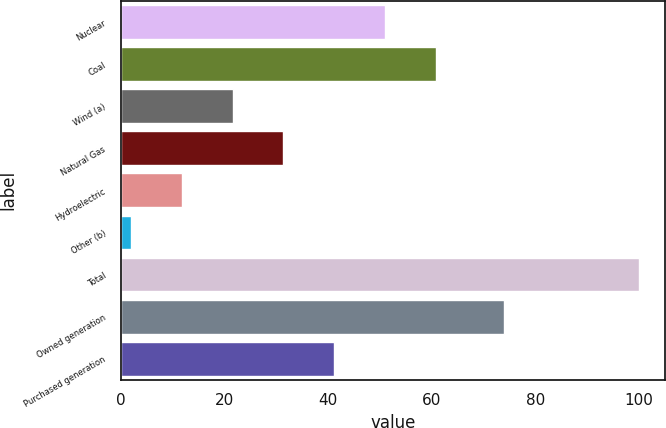Convert chart to OTSL. <chart><loc_0><loc_0><loc_500><loc_500><bar_chart><fcel>Nuclear<fcel>Coal<fcel>Wind (a)<fcel>Natural Gas<fcel>Hydroelectric<fcel>Other (b)<fcel>Total<fcel>Owned generation<fcel>Purchased generation<nl><fcel>51<fcel>60.8<fcel>21.6<fcel>31.4<fcel>11.8<fcel>2<fcel>100<fcel>74<fcel>41.2<nl></chart> 